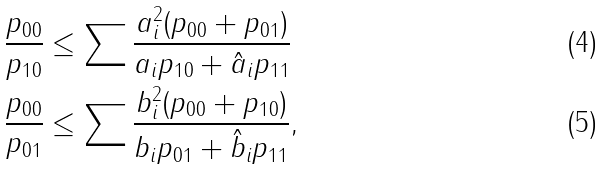<formula> <loc_0><loc_0><loc_500><loc_500>\frac { p _ { 0 0 } } { p _ { 1 0 } } & \leq \sum \frac { a _ { i } ^ { 2 } ( p _ { 0 0 } + p _ { 0 1 } ) } { a _ { i } p _ { 1 0 } + \hat { a } _ { i } p _ { 1 1 } } \\ \frac { p _ { 0 0 } } { p _ { 0 1 } } & \leq \sum \frac { b _ { i } ^ { 2 } ( p _ { 0 0 } + p _ { 1 0 } ) } { b _ { i } p _ { 0 1 } + \hat { b } _ { i } p _ { 1 1 } } ,</formula> 